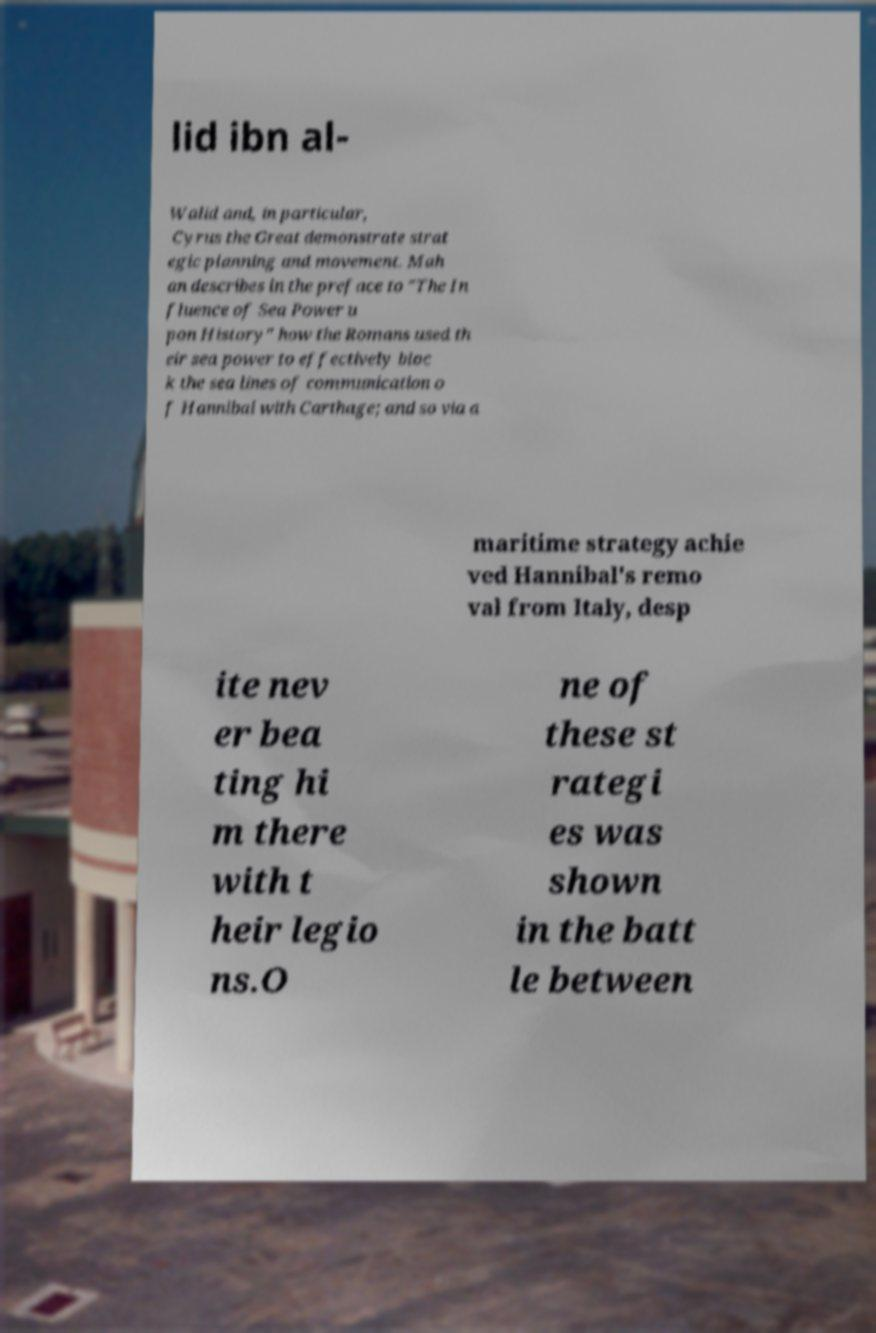Can you read and provide the text displayed in the image?This photo seems to have some interesting text. Can you extract and type it out for me? lid ibn al- Walid and, in particular, Cyrus the Great demonstrate strat egic planning and movement. Mah an describes in the preface to "The In fluence of Sea Power u pon History" how the Romans used th eir sea power to effectively bloc k the sea lines of communication o f Hannibal with Carthage; and so via a maritime strategy achie ved Hannibal's remo val from Italy, desp ite nev er bea ting hi m there with t heir legio ns.O ne of these st rategi es was shown in the batt le between 